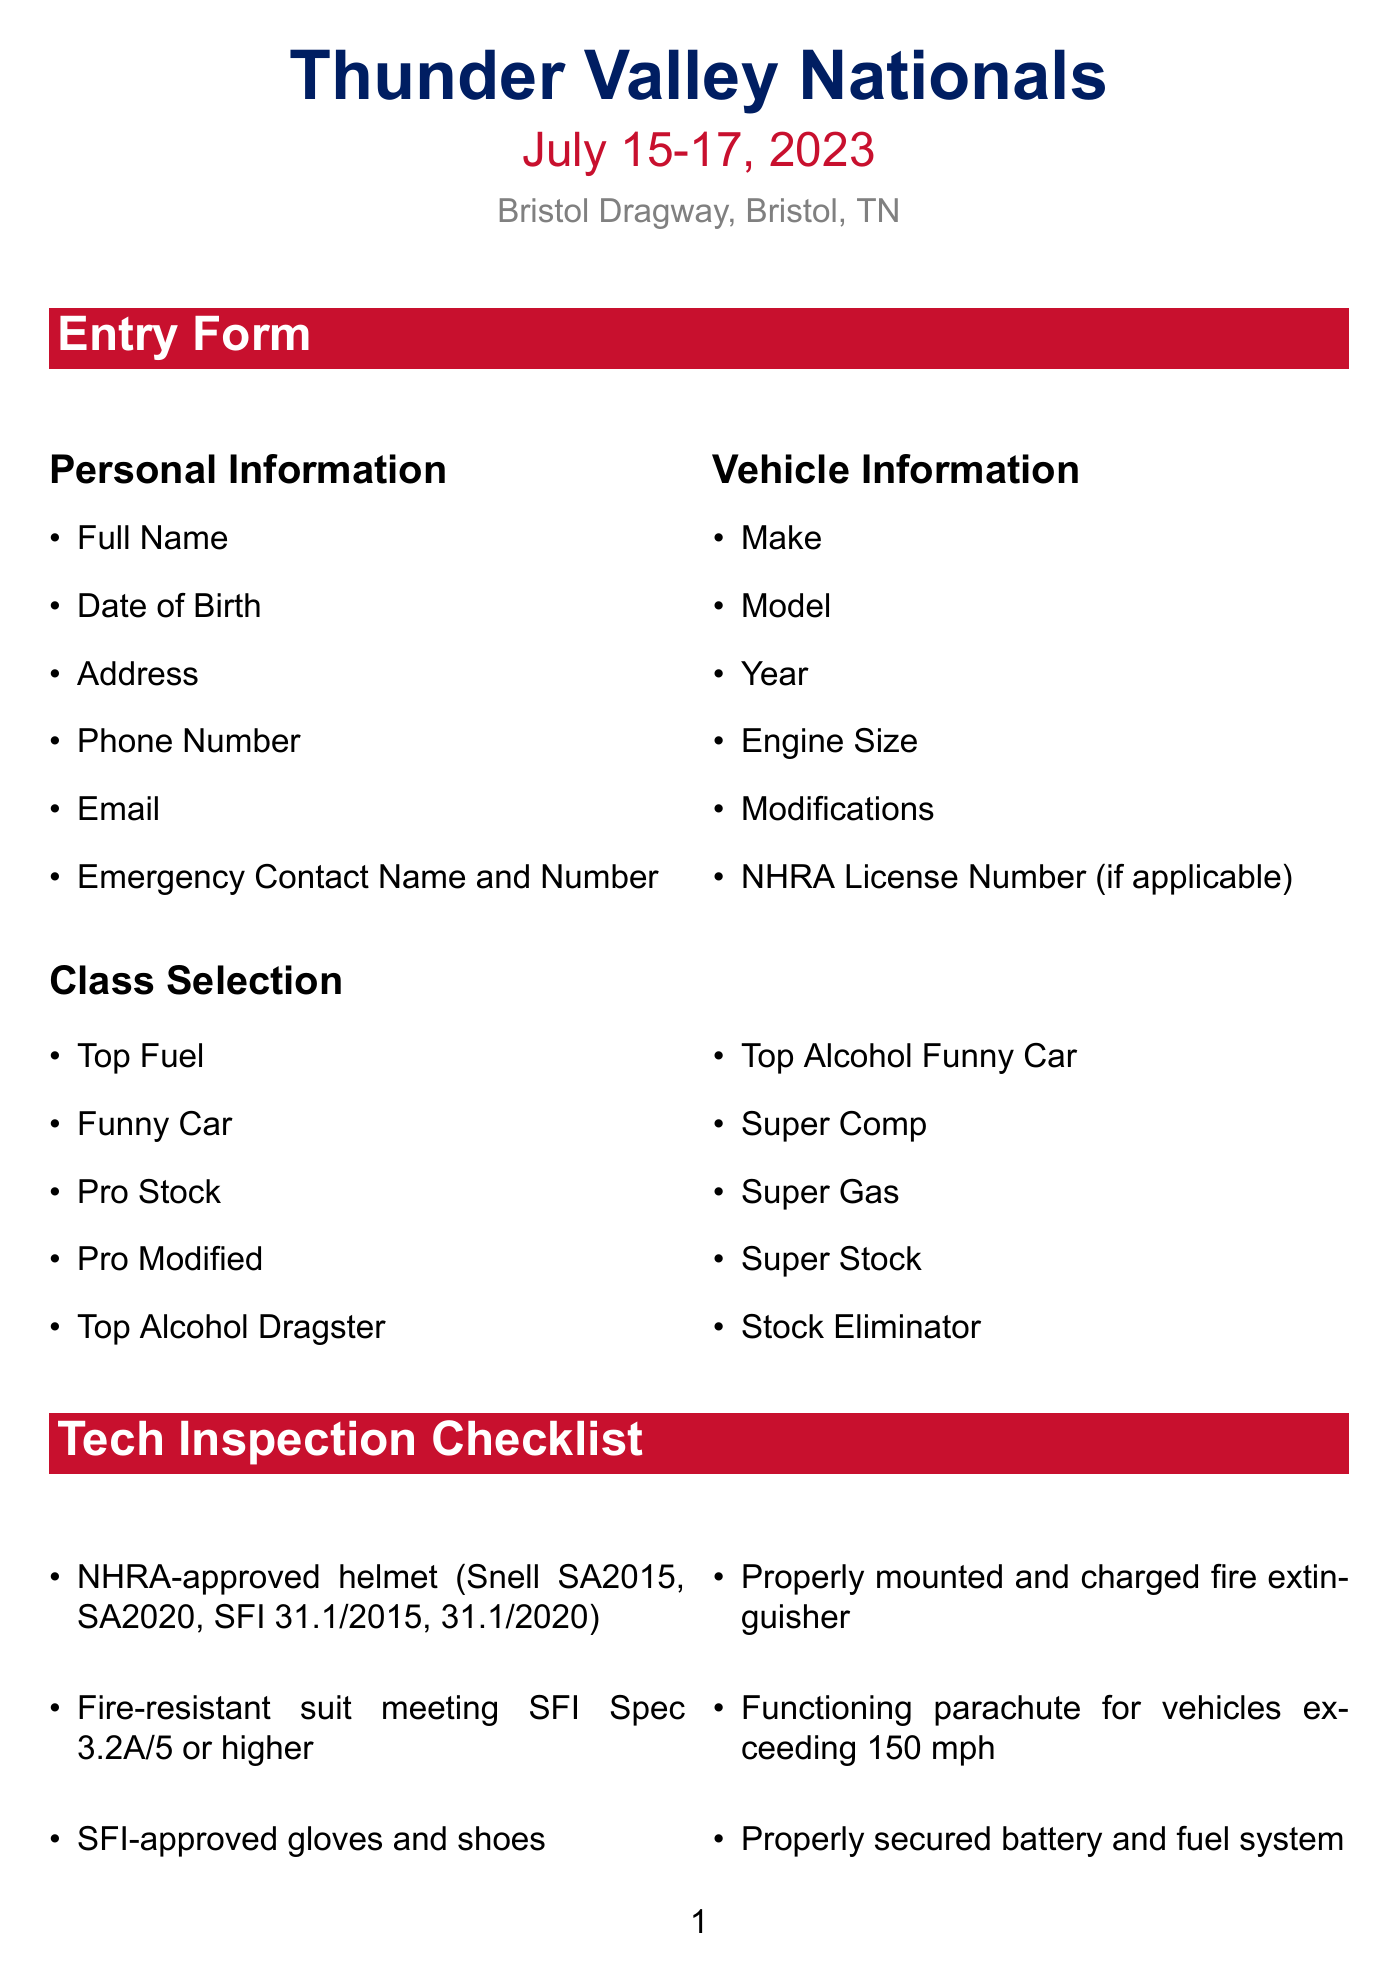what is the name of the event? The name of the event is clearly stated in the document.
Answer: Thunder Valley Nationals what are the dates of the event? The event dates are specified in the document.
Answer: July 15-17, 2023 how many classes can participants select? The number of classes can be counted from the class selection section in the document.
Answer: 10 what is one of the requirements for the safety harness? Specific safety requirements are listed in the tech inspection checklist.
Answer: SFI Spec 16.1 or 16.5 what should a participant do if something doesn't feel right before a run? This advice is given in the safety reminders section of the document.
Answer: Abort the run what is required for medical consent in the waiver? The consent requirement is mentioned in the liability waiver section.
Answer: Consent to medical treatment in case of emergency which vehicle modification is listed in the vehicle information? The document contains a list of vehicle information including modifications.
Answer: Modifications what is the purpose of the "Coach's Corner"? The purpose is to provide wisdom and tips for racers.
Answer: Wisdom from the Strip how many signatures are required in the liability waiver? The waiver section specifies the number of signatures needed.
Answer: 3 